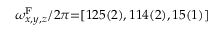Convert formula to latex. <formula><loc_0><loc_0><loc_500><loc_500>\omega _ { x , y , z } ^ { F } / 2 \pi { = } [ 1 2 5 ( 2 ) , 1 1 4 ( 2 ) , 1 5 ( 1 ) ]</formula> 